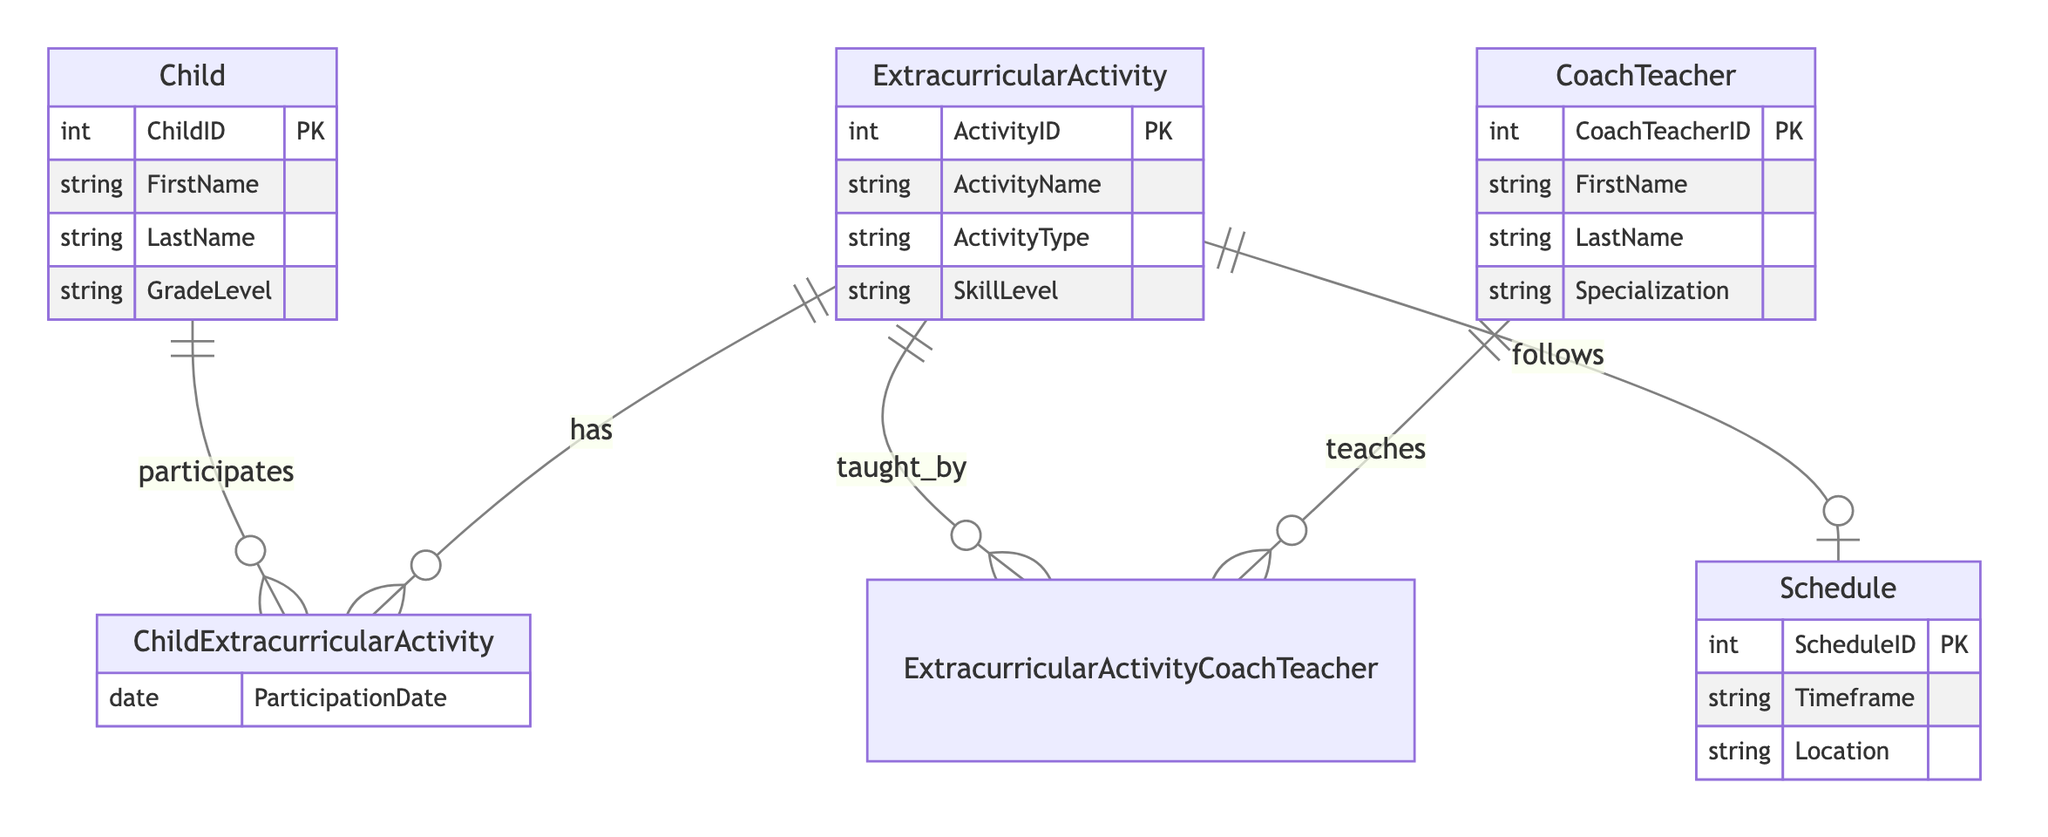What type of relationship exists between Child and Extracurricular Activity? The diagram indicates that the relationship between Child and Extracurricular Activity is ManyToMany, meaning one child can participate in multiple activities and each activity can have multiple children participating.
Answer: ManyToMany How many primary keys are defined in the CoachTeacher entity? The CoachTeacher entity has one primary key defined, which is CoachTeacherID, according to the attributes specified.
Answer: One What attribute is used to track when a child participates in an extracurricular activity? The participation date is tracked by the attribute named ParticipationDate within the ChildExtracurricularActivity relationship, allowing for the recording of the date a child participates in each activity.
Answer: ParticipationDate What entities are involved in the relationship taught_by? The taught_by relationship connects the Extracurricular Activity and CoachTeacher entities, indicating that activities can be taught by multiple coaches or teachers and each teacher can teach various activities.
Answer: Extracurricular Activity, CoachTeacher How many attributes are defined for the Schedule entity? The Schedule entity has three attributes defined: Timeframe, Location, and ScheduleID, which serves as the primary key for this entity.
Answer: Three Can a single activity have multiple coaches or teachers associated with it? Yes, the relationship defined as taught_by indicates that an extracurricular activity can be associated with multiple coaches or teachers. This suggests a ManyToMany relationship for coaching or teaching.
Answer: Yes What is the primary key for the Child entity? The primary key for the Child entity is ChildID, which uniquely identifies each child in the system.
Answer: ChildID How many distinct relationships are defined in the diagram? The diagram outlines three distinct relationships: ChildExtracurricularActivity, ExtracurricularActivityCoachTeacher, and ExtracurricularActivitySchedule, which connect the respective entities in various manners.
Answer: Three What attribute is common to both the CoachTeacher and Child entities in this diagram? The CoachTeacher and Child entities do not share any common attribute; they both have distinct attributes defined for their respective identities, such as ChildID for Child and CoachTeacherID for CoachTeacher.
Answer: None 